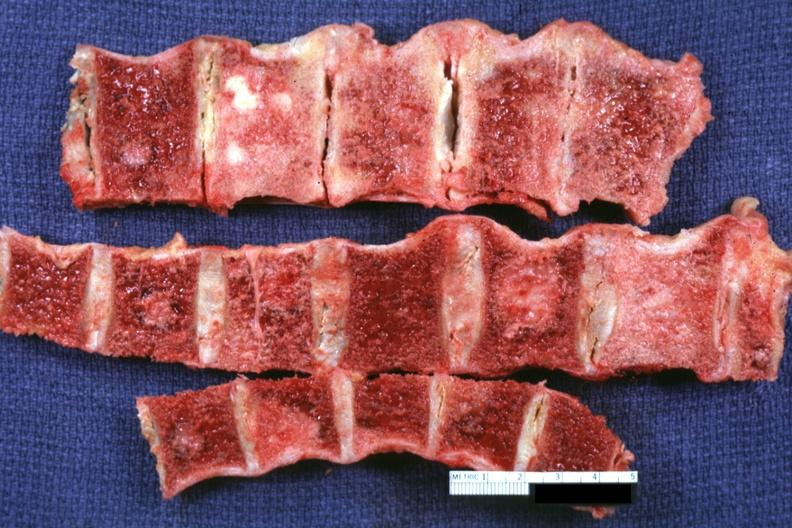what is present?
Answer the question using a single word or phrase. Joints 